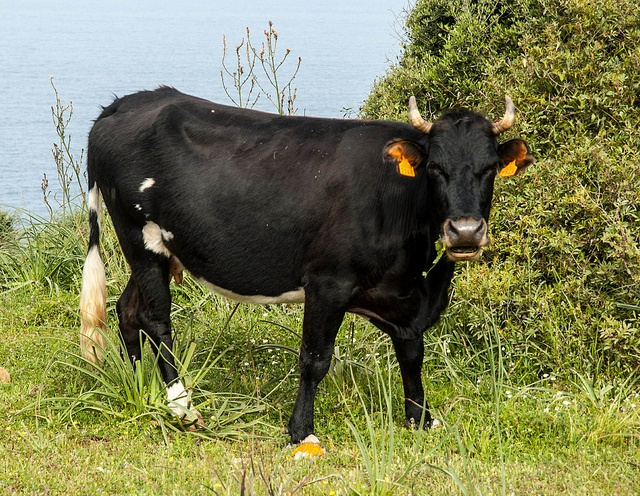Describe the objects in this image and their specific colors. I can see a cow in lightblue, black, gray, and darkgreen tones in this image. 